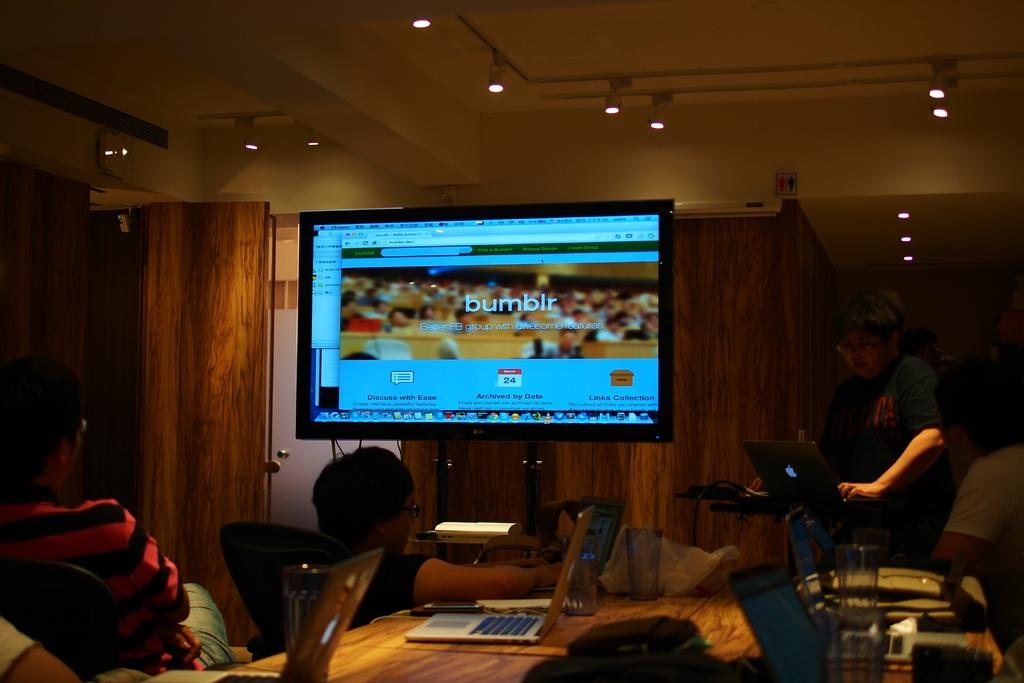<image>
Share a concise interpretation of the image provided. In a meeting room a large monitor shows the bumbler website. 